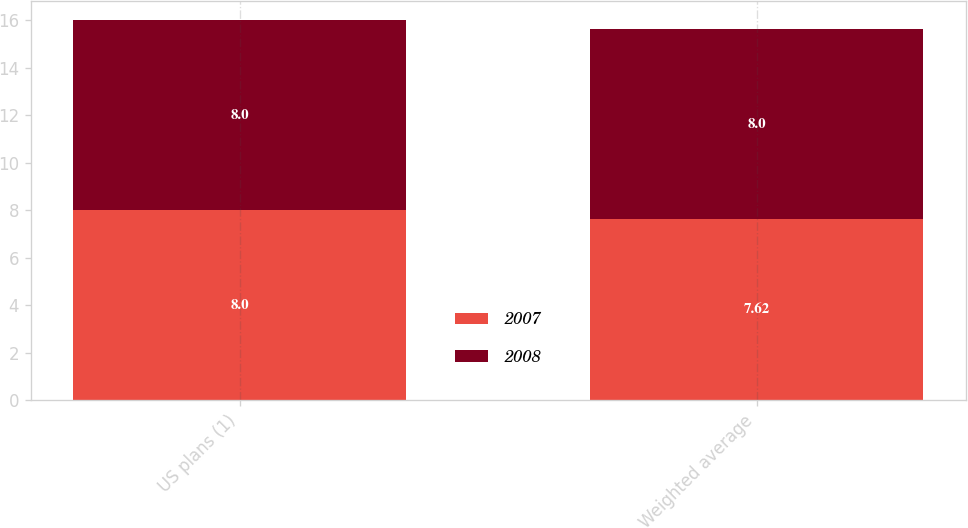Convert chart to OTSL. <chart><loc_0><loc_0><loc_500><loc_500><stacked_bar_chart><ecel><fcel>US plans (1)<fcel>Weighted average<nl><fcel>2007<fcel>8<fcel>7.62<nl><fcel>2008<fcel>8<fcel>8<nl></chart> 